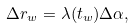<formula> <loc_0><loc_0><loc_500><loc_500>\Delta r _ { w } = \lambda ( t _ { w } ) \Delta \alpha ,</formula> 